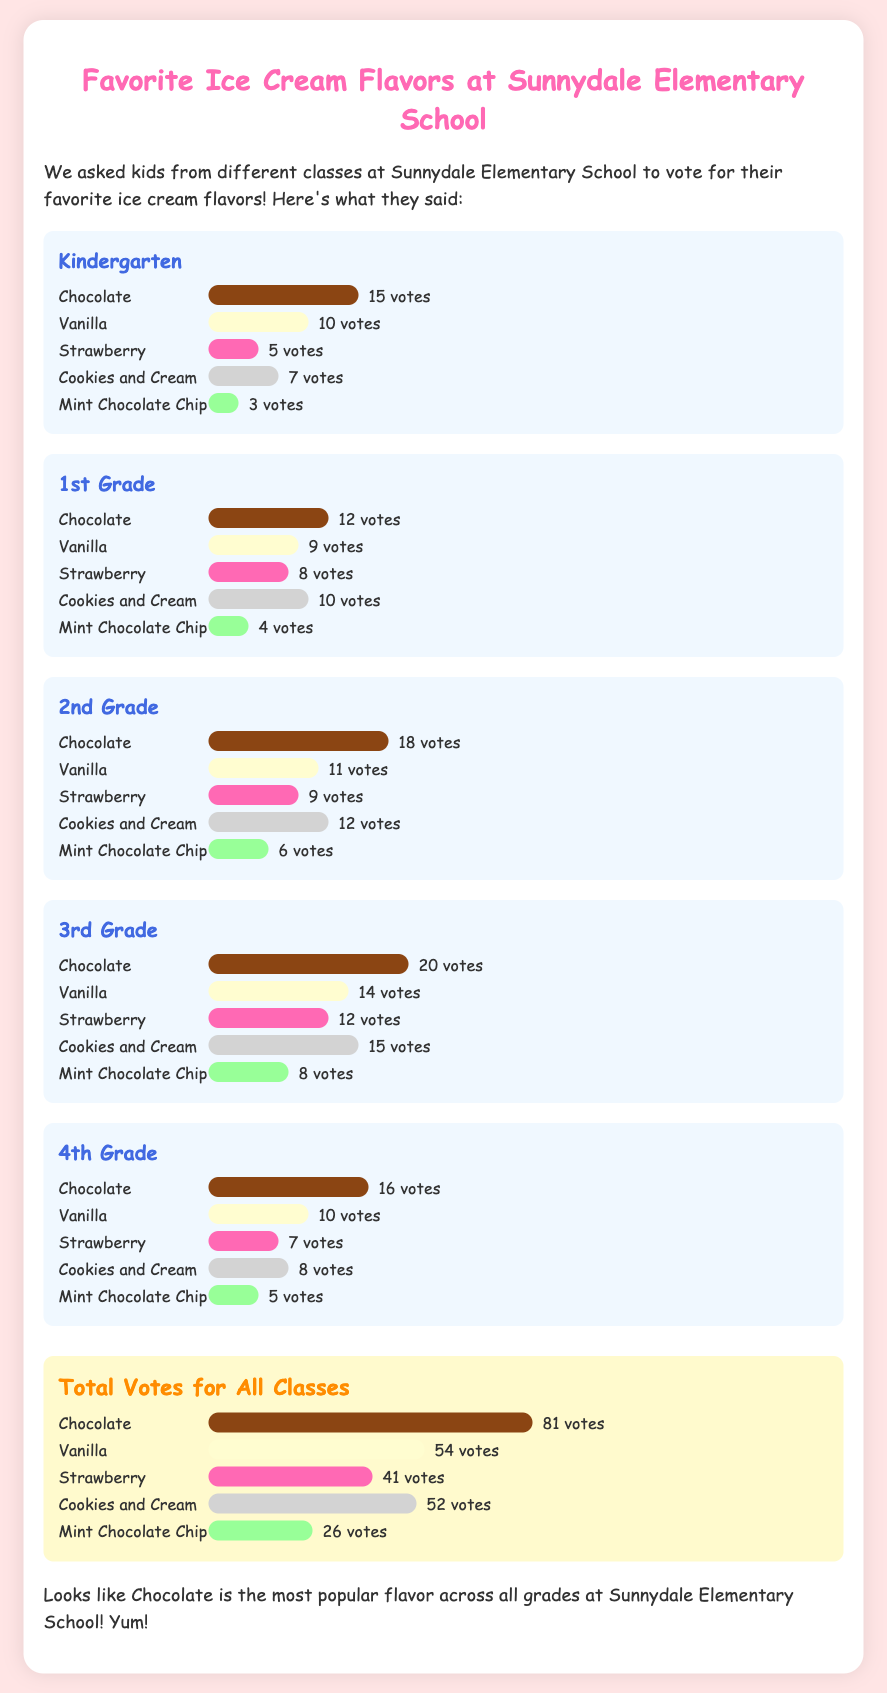What is the most popular ice cream flavor? The most popular ice cream flavor is determined by the highest number of votes received across all classes, which is Chocolate with 81 votes.
Answer: Chocolate How many votes did Vanilla get in 2nd Grade? The document states that Vanilla received 11 votes in the 2nd Grade class.
Answer: 11 votes Which flavor had the least votes in Kindergarten? The least votes in Kindergarten was for Mint Chocolate Chip, which received 3 votes.
Answer: Mint Chocolate Chip How many total votes were counted across all flavors? The total number of votes can be calculated by adding the votes for all flavors: 81 + 54 + 41 + 52 + 26 = 254 votes in total.
Answer: 254 votes Which class had the highest votes for Chocolate? The class with the highest votes for Chocolate is the 3rd Grade, which received 20 votes.
Answer: 3rd Grade How many votes did Cookies and Cream receive in 4th Grade? In the 4th Grade, Cookies and Cream received 8 votes.
Answer: 8 votes What is the total number of votes for Mint Chocolate Chip across all grades? To find the total votes for Mint Chocolate Chip, we add the votes from all classes: 3 + 4 + 6 + 8 + 5 = 26 votes.
Answer: 26 votes How many votes did Strawberry receive in 1st Grade? In 1st Grade, Strawberry received 8 votes as stated in the document.
Answer: 8 votes 